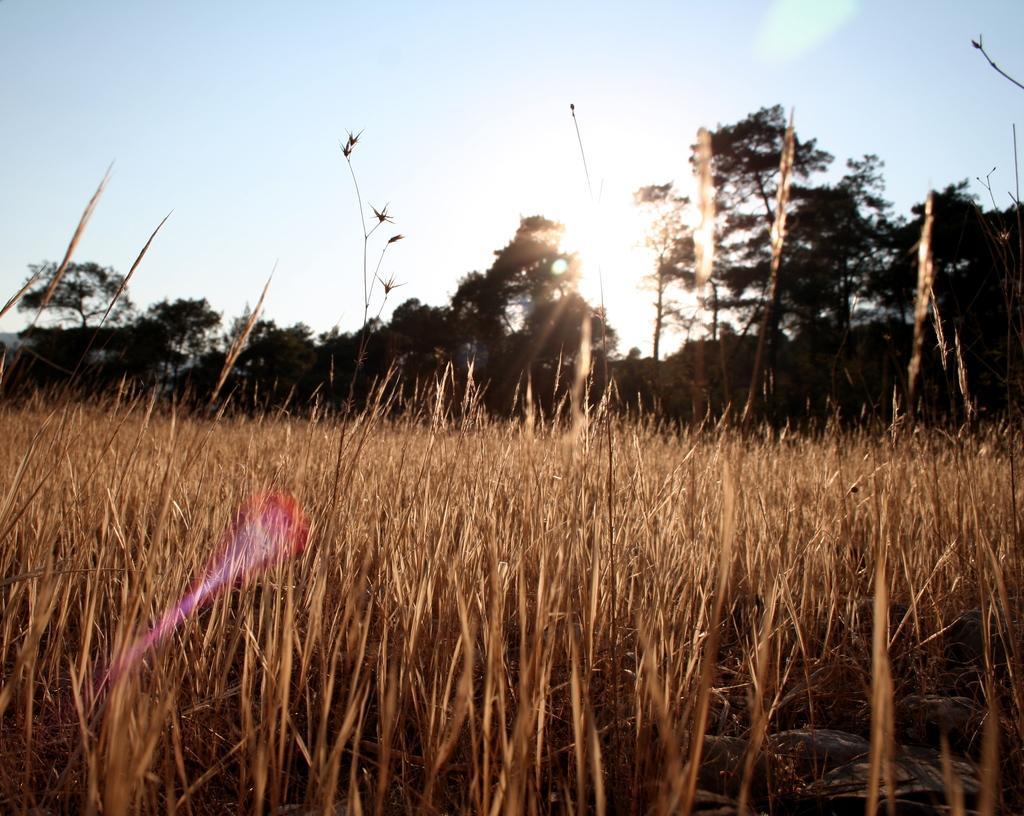Could you give a brief overview of what you see in this image? In this image, we can see grass and ground. Background there are few trees and sky. 